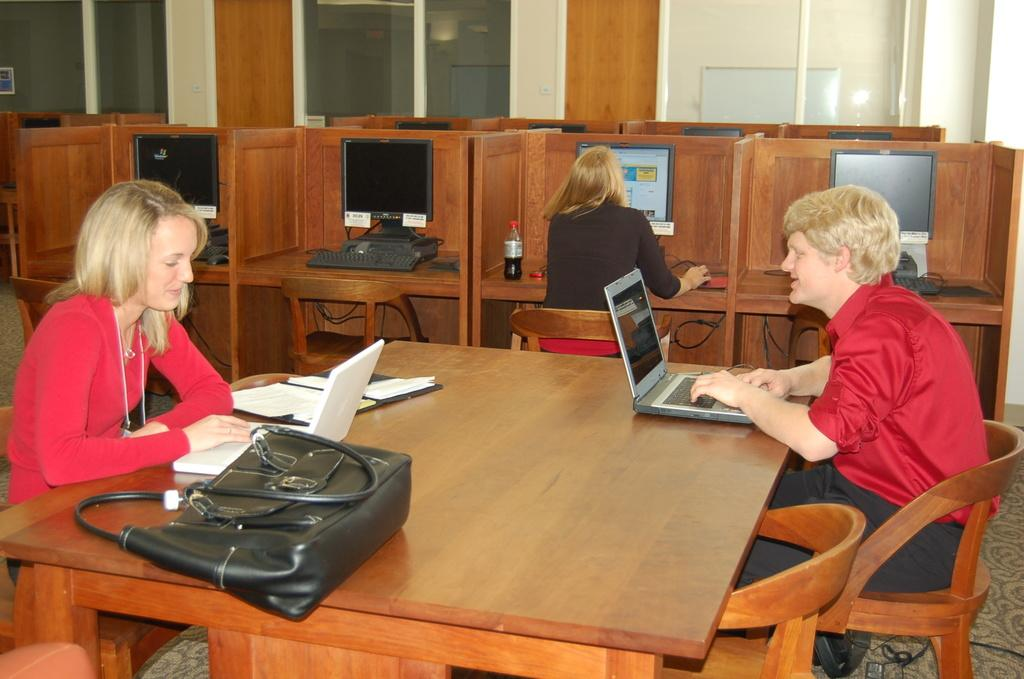How many people are in the image? There are three people in the image: one man and two women. What are the people in the image doing? The man and women are sitting on chairs. What type of electronic devices can be seen in the image? There are computers and laptops in the image. What accessory is present in the image? There is a handbag in the image. What type of pets are visible in the image? There are no pets visible in the image. How many walls are present in the image? There is no mention of walls in the provided facts, so it cannot be determined from the image. 